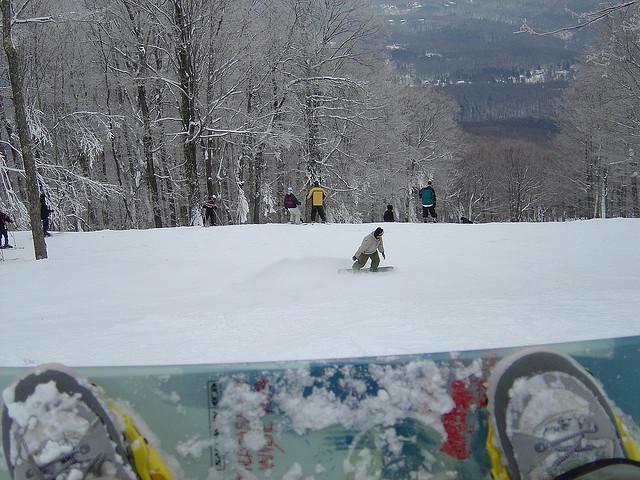How many couches in this image are unoccupied by people?
Give a very brief answer. 0. 